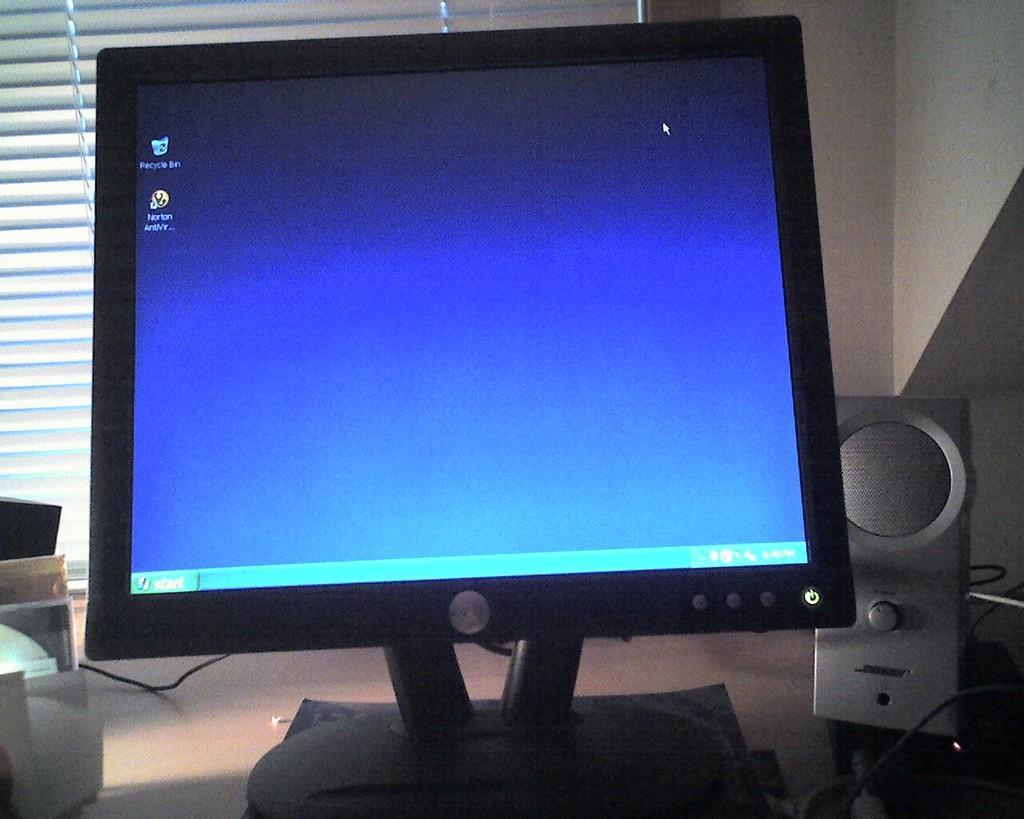In one or two sentences, can you explain what this image depicts? In this image there is a desktop in the middle. Beside the desktop there is a speaker. In the background there is a curtain. On the left side there are cd's. 